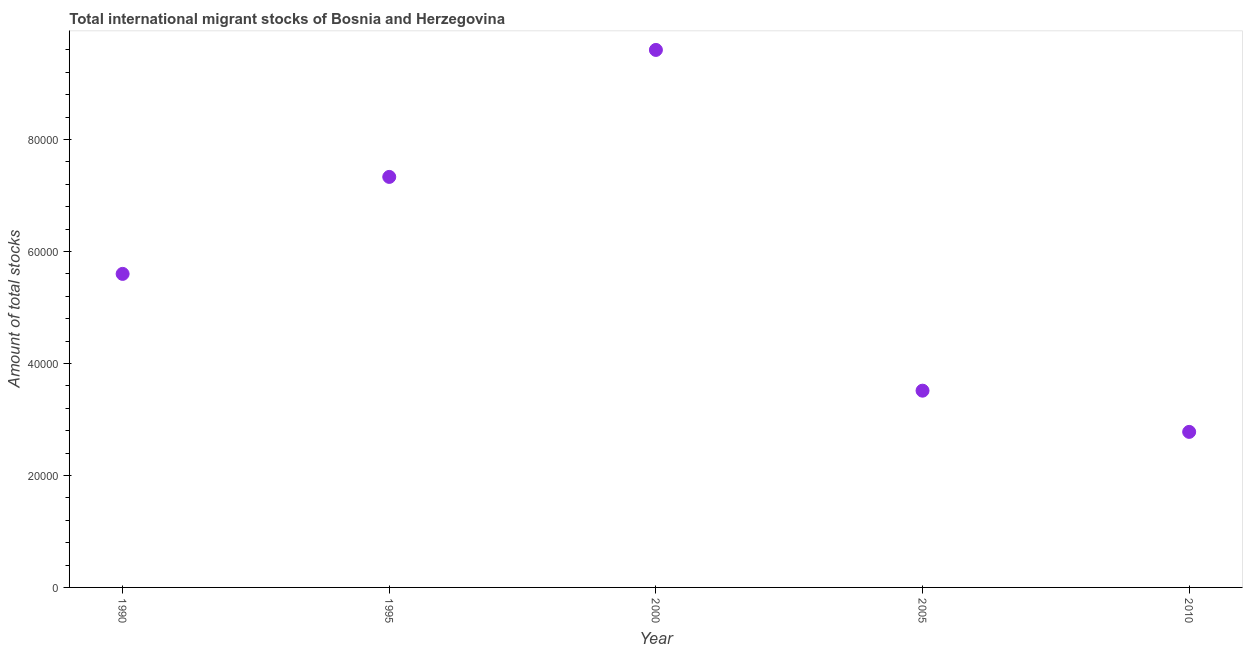What is the total number of international migrant stock in 2005?
Your answer should be compact. 3.51e+04. Across all years, what is the maximum total number of international migrant stock?
Your answer should be compact. 9.60e+04. Across all years, what is the minimum total number of international migrant stock?
Keep it short and to the point. 2.78e+04. In which year was the total number of international migrant stock maximum?
Your answer should be compact. 2000. What is the sum of the total number of international migrant stock?
Provide a short and direct response. 2.88e+05. What is the difference between the total number of international migrant stock in 1990 and 1995?
Keep it short and to the point. -1.73e+04. What is the average total number of international migrant stock per year?
Provide a short and direct response. 5.76e+04. What is the median total number of international migrant stock?
Ensure brevity in your answer.  5.60e+04. In how many years, is the total number of international migrant stock greater than 4000 ?
Offer a terse response. 5. What is the ratio of the total number of international migrant stock in 1990 to that in 2000?
Your response must be concise. 0.58. What is the difference between the highest and the second highest total number of international migrant stock?
Offer a terse response. 2.27e+04. What is the difference between the highest and the lowest total number of international migrant stock?
Provide a succinct answer. 6.82e+04. Does the total number of international migrant stock monotonically increase over the years?
Give a very brief answer. No. How many years are there in the graph?
Offer a terse response. 5. Does the graph contain grids?
Ensure brevity in your answer.  No. What is the title of the graph?
Provide a succinct answer. Total international migrant stocks of Bosnia and Herzegovina. What is the label or title of the Y-axis?
Your answer should be compact. Amount of total stocks. What is the Amount of total stocks in 1990?
Keep it short and to the point. 5.60e+04. What is the Amount of total stocks in 1995?
Offer a very short reply. 7.33e+04. What is the Amount of total stocks in 2000?
Your answer should be compact. 9.60e+04. What is the Amount of total stocks in 2005?
Keep it short and to the point. 3.51e+04. What is the Amount of total stocks in 2010?
Make the answer very short. 2.78e+04. What is the difference between the Amount of total stocks in 1990 and 1995?
Offer a very short reply. -1.73e+04. What is the difference between the Amount of total stocks in 1990 and 2000?
Provide a short and direct response. -4.00e+04. What is the difference between the Amount of total stocks in 1990 and 2005?
Make the answer very short. 2.09e+04. What is the difference between the Amount of total stocks in 1990 and 2010?
Ensure brevity in your answer.  2.82e+04. What is the difference between the Amount of total stocks in 1995 and 2000?
Your answer should be compact. -2.27e+04. What is the difference between the Amount of total stocks in 1995 and 2005?
Your response must be concise. 3.82e+04. What is the difference between the Amount of total stocks in 1995 and 2010?
Your response must be concise. 4.55e+04. What is the difference between the Amount of total stocks in 2000 and 2005?
Your answer should be very brief. 6.09e+04. What is the difference between the Amount of total stocks in 2000 and 2010?
Offer a very short reply. 6.82e+04. What is the difference between the Amount of total stocks in 2005 and 2010?
Give a very brief answer. 7361. What is the ratio of the Amount of total stocks in 1990 to that in 1995?
Provide a succinct answer. 0.76. What is the ratio of the Amount of total stocks in 1990 to that in 2000?
Your response must be concise. 0.58. What is the ratio of the Amount of total stocks in 1990 to that in 2005?
Your answer should be very brief. 1.59. What is the ratio of the Amount of total stocks in 1990 to that in 2010?
Your response must be concise. 2.02. What is the ratio of the Amount of total stocks in 1995 to that in 2000?
Make the answer very short. 0.76. What is the ratio of the Amount of total stocks in 1995 to that in 2005?
Provide a succinct answer. 2.09. What is the ratio of the Amount of total stocks in 1995 to that in 2010?
Your answer should be very brief. 2.64. What is the ratio of the Amount of total stocks in 2000 to that in 2005?
Your response must be concise. 2.73. What is the ratio of the Amount of total stocks in 2000 to that in 2010?
Provide a succinct answer. 3.46. What is the ratio of the Amount of total stocks in 2005 to that in 2010?
Your response must be concise. 1.26. 